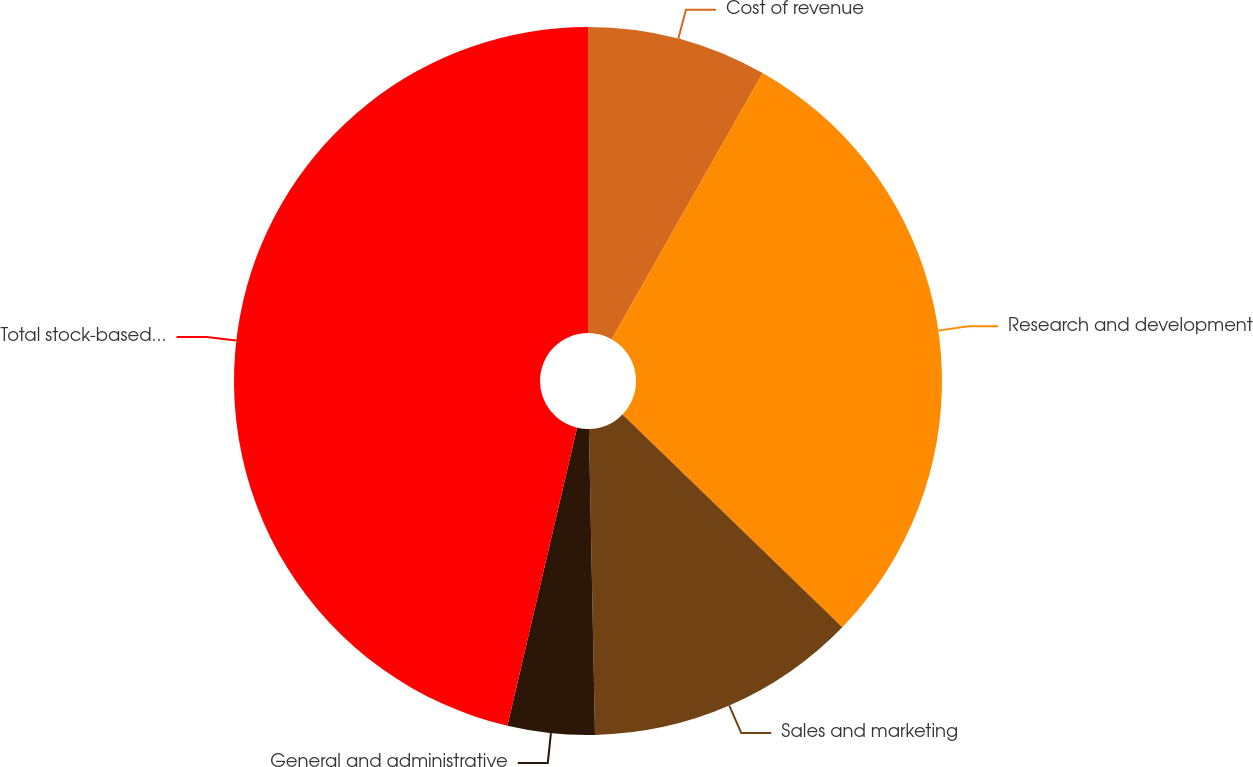Convert chart to OTSL. <chart><loc_0><loc_0><loc_500><loc_500><pie_chart><fcel>Cost of revenue<fcel>Research and development<fcel>Sales and marketing<fcel>General and administrative<fcel>Total stock-based compensation<nl><fcel>8.21%<fcel>29.03%<fcel>12.44%<fcel>3.97%<fcel>46.34%<nl></chart> 